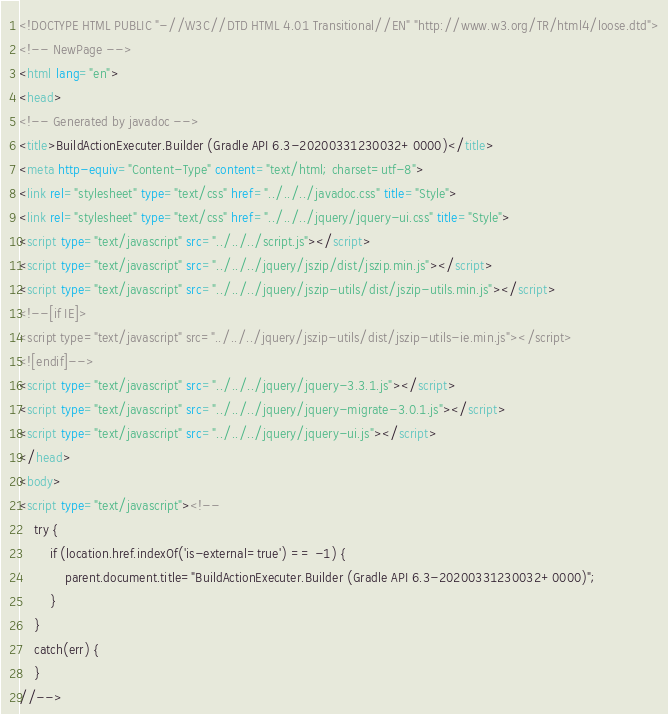Convert code to text. <code><loc_0><loc_0><loc_500><loc_500><_HTML_><!DOCTYPE HTML PUBLIC "-//W3C//DTD HTML 4.01 Transitional//EN" "http://www.w3.org/TR/html4/loose.dtd">
<!-- NewPage -->
<html lang="en">
<head>
<!-- Generated by javadoc -->
<title>BuildActionExecuter.Builder (Gradle API 6.3-20200331230032+0000)</title>
<meta http-equiv="Content-Type" content="text/html; charset=utf-8">
<link rel="stylesheet" type="text/css" href="../../../javadoc.css" title="Style">
<link rel="stylesheet" type="text/css" href="../../../jquery/jquery-ui.css" title="Style">
<script type="text/javascript" src="../../../script.js"></script>
<script type="text/javascript" src="../../../jquery/jszip/dist/jszip.min.js"></script>
<script type="text/javascript" src="../../../jquery/jszip-utils/dist/jszip-utils.min.js"></script>
<!--[if IE]>
<script type="text/javascript" src="../../../jquery/jszip-utils/dist/jszip-utils-ie.min.js"></script>
<![endif]-->
<script type="text/javascript" src="../../../jquery/jquery-3.3.1.js"></script>
<script type="text/javascript" src="../../../jquery/jquery-migrate-3.0.1.js"></script>
<script type="text/javascript" src="../../../jquery/jquery-ui.js"></script>
</head>
<body>
<script type="text/javascript"><!--
    try {
        if (location.href.indexOf('is-external=true') == -1) {
            parent.document.title="BuildActionExecuter.Builder (Gradle API 6.3-20200331230032+0000)";
        }
    }
    catch(err) {
    }
//--></code> 